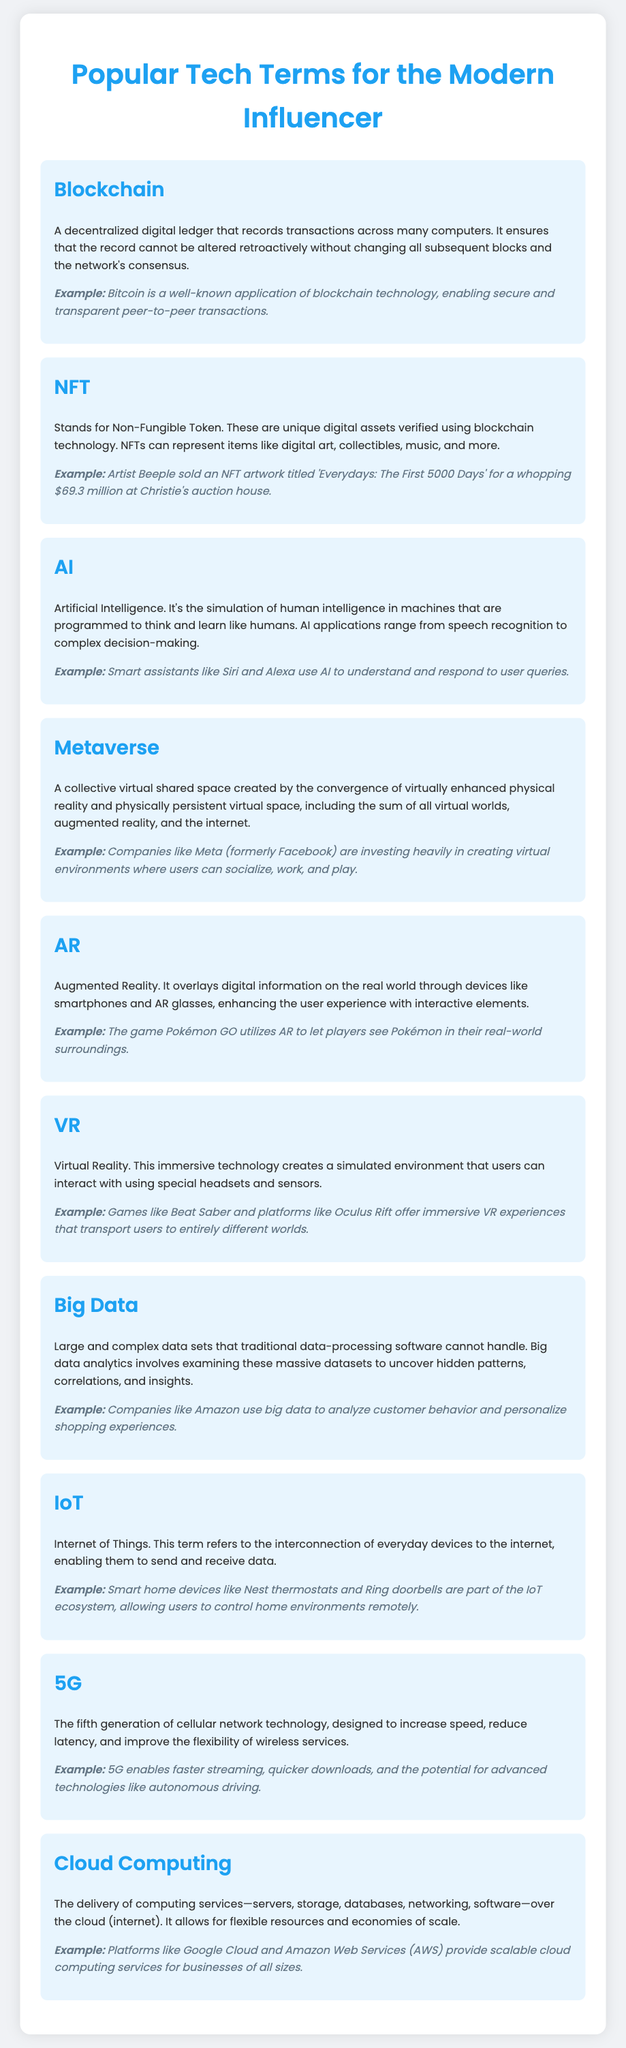What is a key feature of blockchain? Blockchain records transactions in a decentralized manner, ensuring the record cannot be altered retroactively.
Answer: Decentralized digital ledger Who sold an NFT artwork for $69.3 million? Beeple is the artist known for selling an NFT artwork titled 'Everydays: The First 5000 Days' for this amount.
Answer: Beeple What does AI stand for? The abbreviation AI refers to Artificial Intelligence.
Answer: Artificial Intelligence What is the name of the virtual space created by converged environments? The term used to describe this collective virtual shared space is the metaverse.
Answer: Metaverse What technology improves wireless service flexibility? The fifth generation of cellular network technology is known as 5G, which enhances these capabilities.
Answer: 5G Which technology allows devices like thermostats to connect to the internet? The term for the interconnection of everyday devices to the internet is the Internet of Things.
Answer: Internet of Things What platform is known for scalable cloud computing services? Amazon Web Services is a well-known platform for providing these services.
Answer: Amazon Web Services What game uses augmented reality to reveal Pokémon in real-world surroundings? Pokémon GO is a popular game that utilizes AR technology.
Answer: Pokémon GO Which technology provides immersive experiences using headsets? Virtual Reality is the immersive technology that uses special headsets for such experiences.
Answer: Virtual Reality 